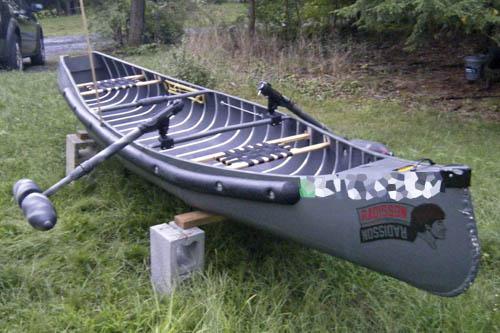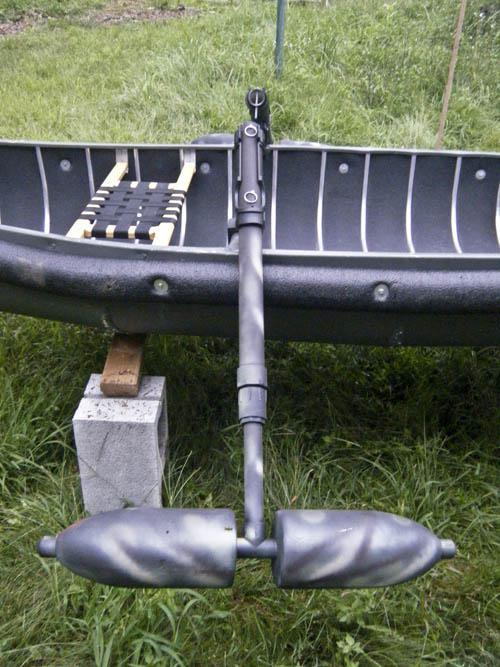The first image is the image on the left, the second image is the image on the right. Considering the images on both sides, is "At least one person is in a boat floating on water." valid? Answer yes or no. No. The first image is the image on the left, the second image is the image on the right. Assess this claim about the two images: "An image shows at least one person in a yellow canoe on the water.". Correct or not? Answer yes or no. No. 